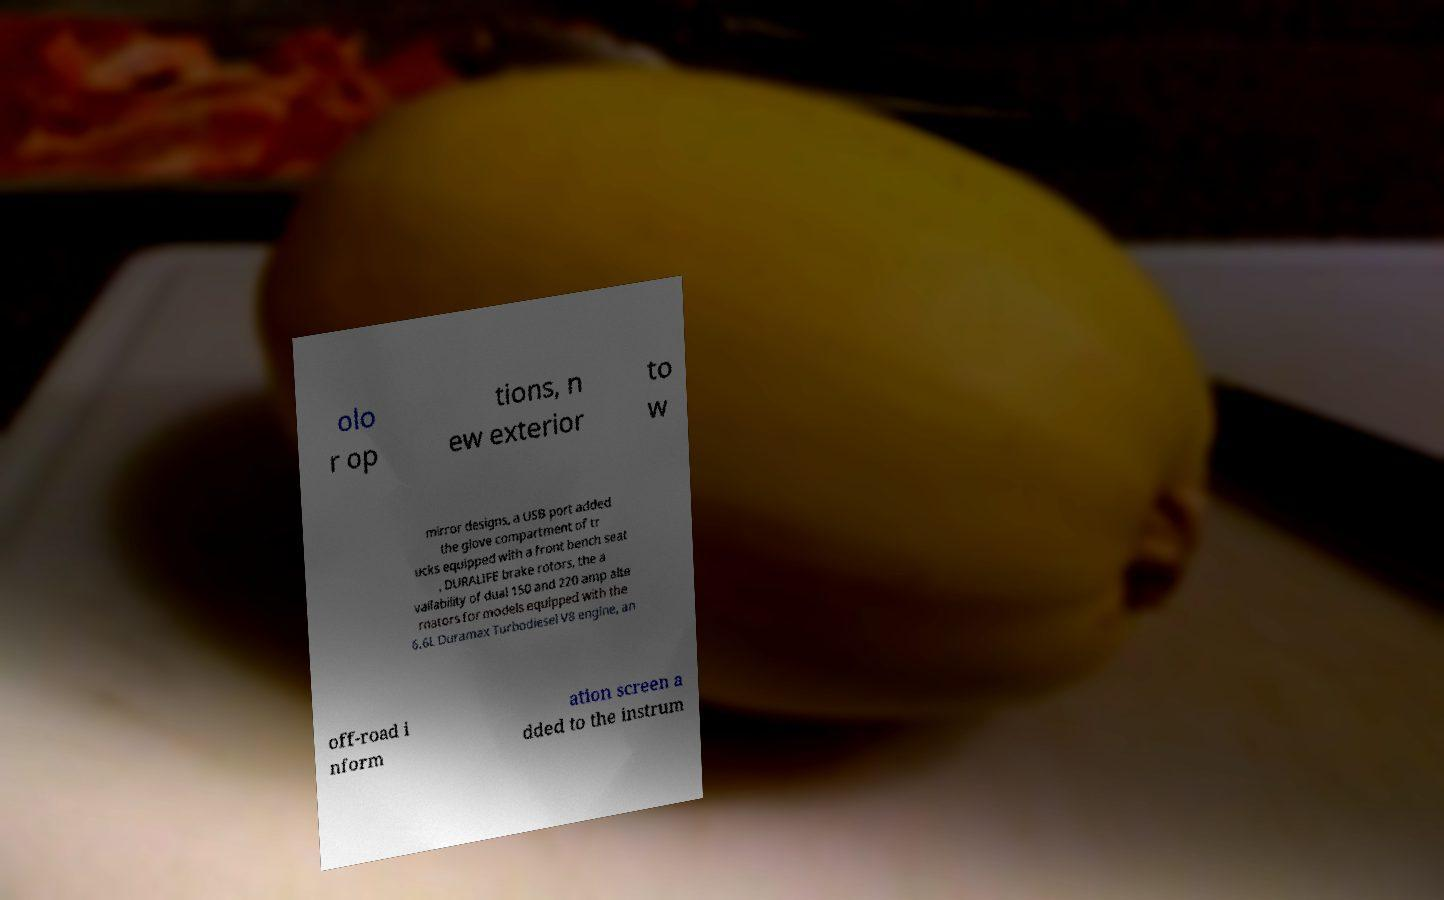What messages or text are displayed in this image? I need them in a readable, typed format. olo r op tions, n ew exterior to w mirror designs, a USB port added the glove compartment of tr ucks equipped with a front bench seat , DURALIFE brake rotors, the a vailability of dual 150 and 220 amp alte rnators for models equipped with the 6.6L Duramax Turbodiesel V8 engine, an off-road i nform ation screen a dded to the instrum 